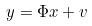Convert formula to latex. <formula><loc_0><loc_0><loc_500><loc_500>y = \Phi x + v</formula> 